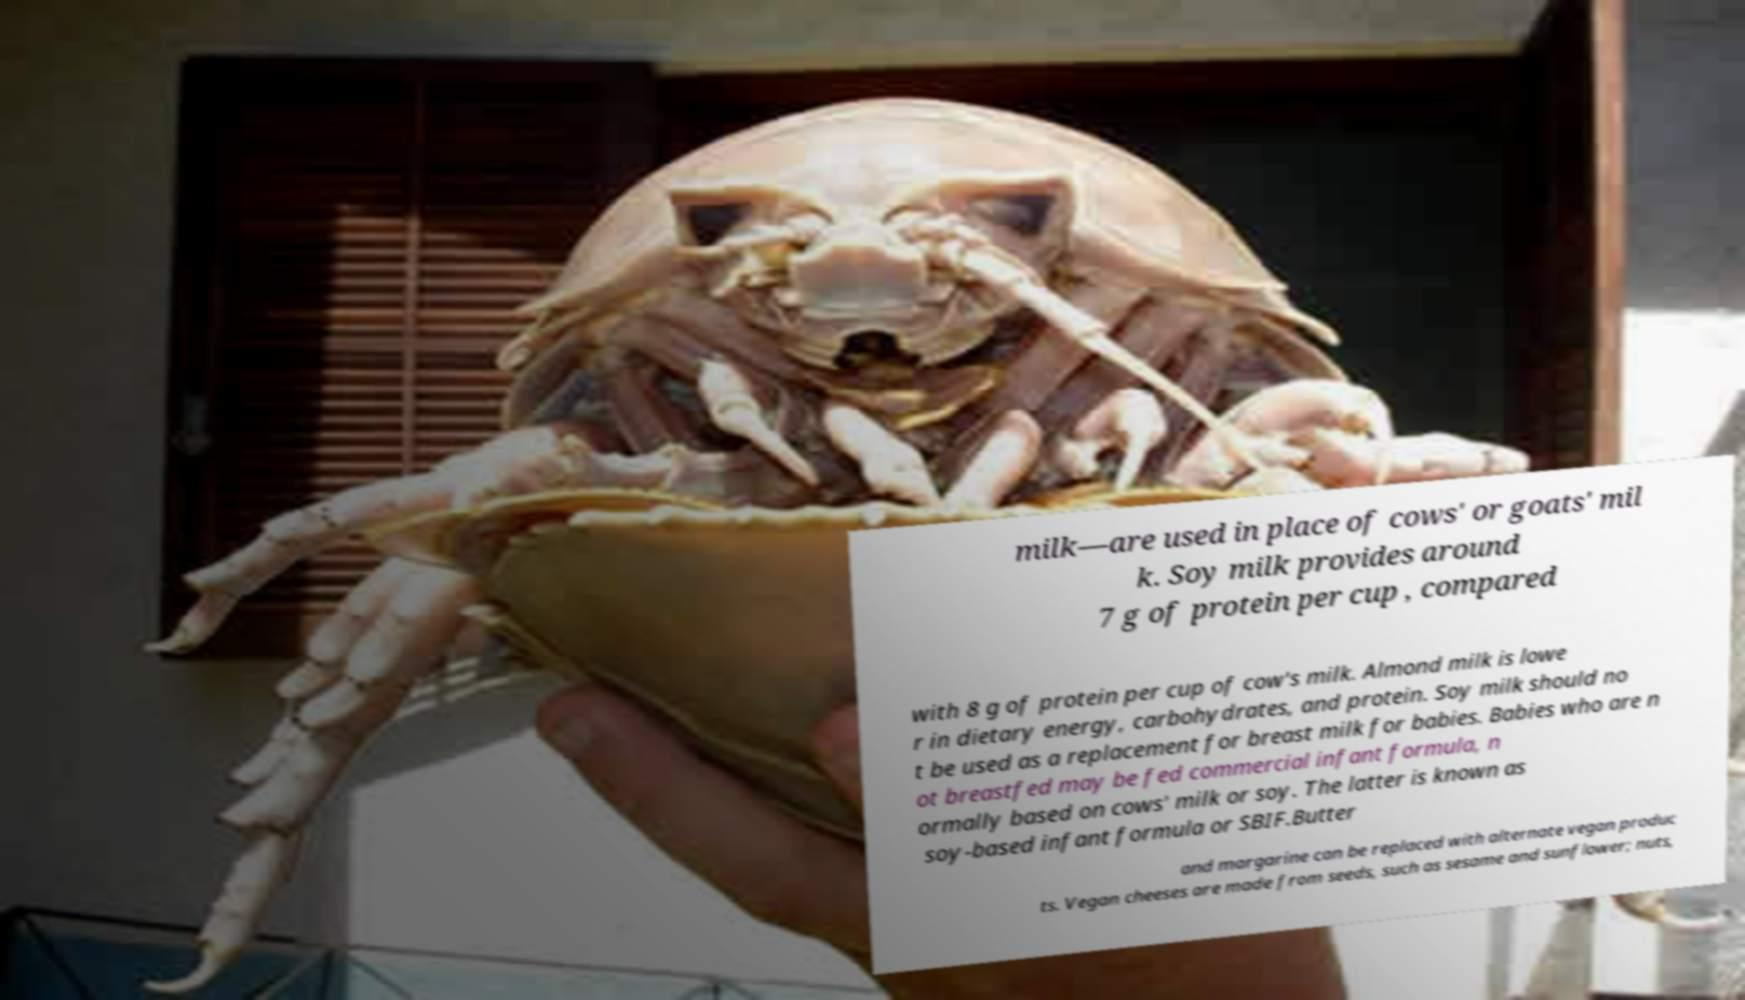What messages or text are displayed in this image? I need them in a readable, typed format. milk—are used in place of cows' or goats' mil k. Soy milk provides around 7 g of protein per cup , compared with 8 g of protein per cup of cow's milk. Almond milk is lowe r in dietary energy, carbohydrates, and protein. Soy milk should no t be used as a replacement for breast milk for babies. Babies who are n ot breastfed may be fed commercial infant formula, n ormally based on cows' milk or soy. The latter is known as soy-based infant formula or SBIF.Butter and margarine can be replaced with alternate vegan produc ts. Vegan cheeses are made from seeds, such as sesame and sunflower; nuts, 